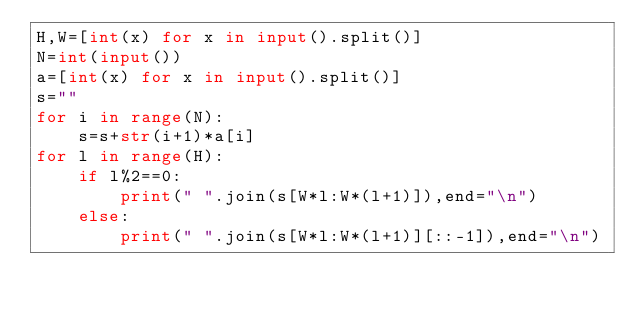Convert code to text. <code><loc_0><loc_0><loc_500><loc_500><_Python_>H,W=[int(x) for x in input().split()]
N=int(input())
a=[int(x) for x in input().split()]
s=""
for i in range(N):
    s=s+str(i+1)*a[i]
for l in range(H):
    if l%2==0:
        print(" ".join(s[W*l:W*(l+1)]),end="\n")
    else:
        print(" ".join(s[W*l:W*(l+1)][::-1]),end="\n")</code> 